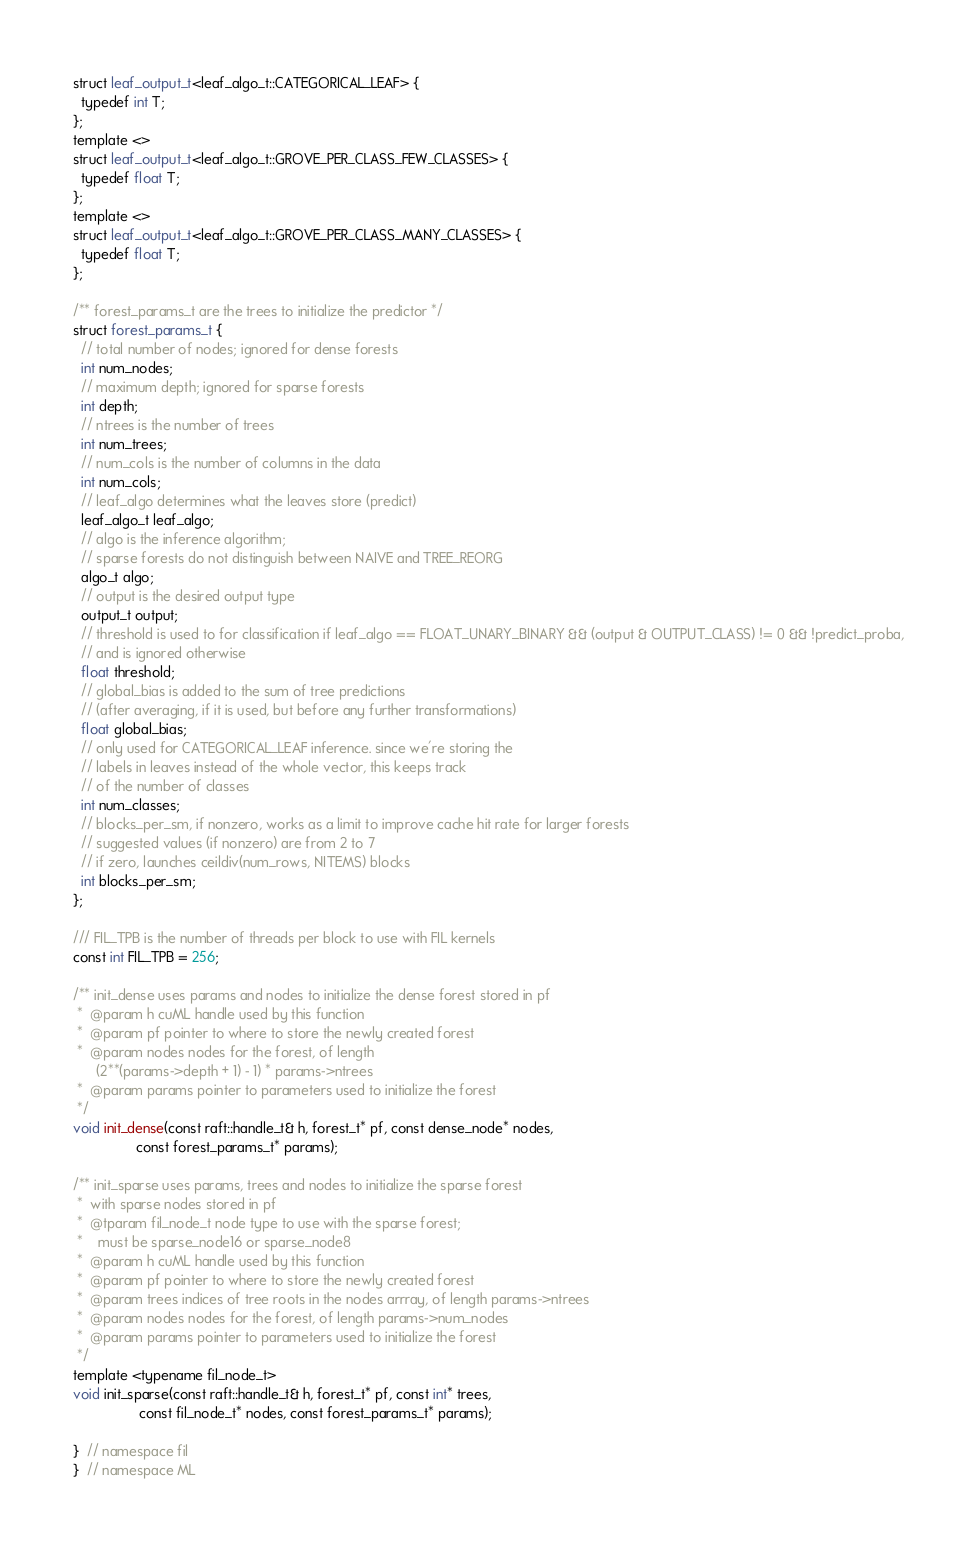Convert code to text. <code><loc_0><loc_0><loc_500><loc_500><_Cuda_>struct leaf_output_t<leaf_algo_t::CATEGORICAL_LEAF> {
  typedef int T;
};
template <>
struct leaf_output_t<leaf_algo_t::GROVE_PER_CLASS_FEW_CLASSES> {
  typedef float T;
};
template <>
struct leaf_output_t<leaf_algo_t::GROVE_PER_CLASS_MANY_CLASSES> {
  typedef float T;
};

/** forest_params_t are the trees to initialize the predictor */
struct forest_params_t {
  // total number of nodes; ignored for dense forests
  int num_nodes;
  // maximum depth; ignored for sparse forests
  int depth;
  // ntrees is the number of trees
  int num_trees;
  // num_cols is the number of columns in the data
  int num_cols;
  // leaf_algo determines what the leaves store (predict)
  leaf_algo_t leaf_algo;
  // algo is the inference algorithm;
  // sparse forests do not distinguish between NAIVE and TREE_REORG
  algo_t algo;
  // output is the desired output type
  output_t output;
  // threshold is used to for classification if leaf_algo == FLOAT_UNARY_BINARY && (output & OUTPUT_CLASS) != 0 && !predict_proba,
  // and is ignored otherwise
  float threshold;
  // global_bias is added to the sum of tree predictions
  // (after averaging, if it is used, but before any further transformations)
  float global_bias;
  // only used for CATEGORICAL_LEAF inference. since we're storing the
  // labels in leaves instead of the whole vector, this keeps track
  // of the number of classes
  int num_classes;
  // blocks_per_sm, if nonzero, works as a limit to improve cache hit rate for larger forests
  // suggested values (if nonzero) are from 2 to 7
  // if zero, launches ceildiv(num_rows, NITEMS) blocks
  int blocks_per_sm;
};

/// FIL_TPB is the number of threads per block to use with FIL kernels
const int FIL_TPB = 256;

/** init_dense uses params and nodes to initialize the dense forest stored in pf
 *  @param h cuML handle used by this function
 *  @param pf pointer to where to store the newly created forest
 *  @param nodes nodes for the forest, of length
      (2**(params->depth + 1) - 1) * params->ntrees
 *  @param params pointer to parameters used to initialize the forest
 */
void init_dense(const raft::handle_t& h, forest_t* pf, const dense_node* nodes,
                const forest_params_t* params);

/** init_sparse uses params, trees and nodes to initialize the sparse forest
 *  with sparse nodes stored in pf
 *  @tparam fil_node_t node type to use with the sparse forest;
 *    must be sparse_node16 or sparse_node8
 *  @param h cuML handle used by this function
 *  @param pf pointer to where to store the newly created forest
 *  @param trees indices of tree roots in the nodes arrray, of length params->ntrees
 *  @param nodes nodes for the forest, of length params->num_nodes
 *  @param params pointer to parameters used to initialize the forest
 */
template <typename fil_node_t>
void init_sparse(const raft::handle_t& h, forest_t* pf, const int* trees,
                 const fil_node_t* nodes, const forest_params_t* params);

}  // namespace fil
}  // namespace ML
</code> 